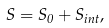Convert formula to latex. <formula><loc_0><loc_0><loc_500><loc_500>S = S _ { 0 } + S _ { i n t } ,</formula> 